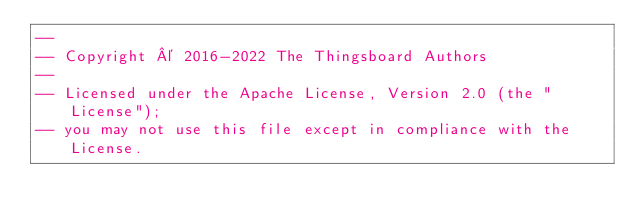<code> <loc_0><loc_0><loc_500><loc_500><_SQL_>--
-- Copyright © 2016-2022 The Thingsboard Authors
--
-- Licensed under the Apache License, Version 2.0 (the "License");
-- you may not use this file except in compliance with the License.</code> 